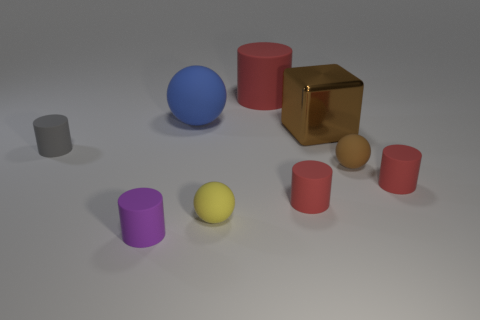Subtract all purple cubes. How many red cylinders are left? 3 Subtract all gray cylinders. How many cylinders are left? 4 Subtract all gray rubber cylinders. How many cylinders are left? 4 Subtract 2 cylinders. How many cylinders are left? 3 Subtract all brown cylinders. Subtract all purple cubes. How many cylinders are left? 5 Add 1 tiny cyan metallic objects. How many objects exist? 10 Subtract all cubes. How many objects are left? 8 Add 4 matte cylinders. How many matte cylinders are left? 9 Add 6 cyan blocks. How many cyan blocks exist? 6 Subtract 0 green balls. How many objects are left? 9 